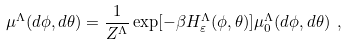<formula> <loc_0><loc_0><loc_500><loc_500>\mu ^ { \Lambda } ( d \phi , d \theta ) = { \frac { 1 } { Z ^ { \Lambda } } } \exp [ - \beta H ^ { \Lambda } _ { \varepsilon } ( \phi , \theta ) ] \mu _ { 0 } ^ { \Lambda } ( d \phi , d \theta ) \ ,</formula> 